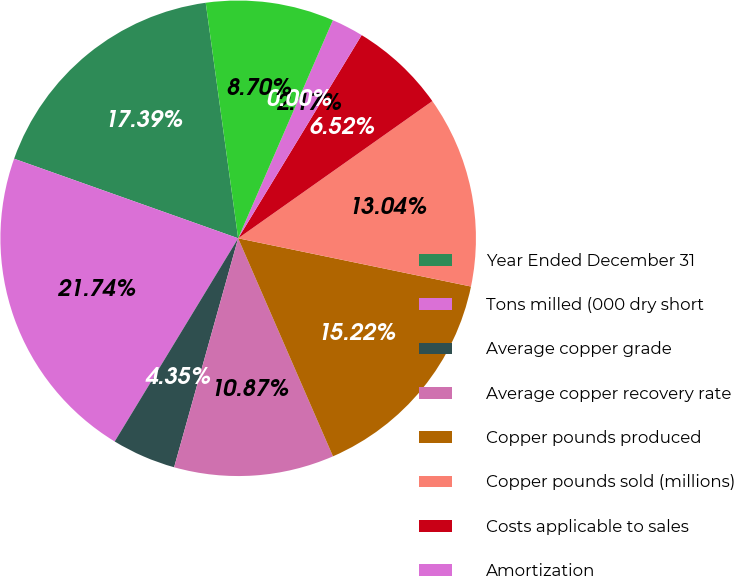<chart> <loc_0><loc_0><loc_500><loc_500><pie_chart><fcel>Year Ended December 31<fcel>Tons milled (000 dry short<fcel>Average copper grade<fcel>Average copper recovery rate<fcel>Copper pounds produced<fcel>Copper pounds sold (millions)<fcel>Costs applicable to sales<fcel>Amortization<fcel>Reclamation/accretion expense<fcel>Total production costs<nl><fcel>17.39%<fcel>21.74%<fcel>4.35%<fcel>10.87%<fcel>15.22%<fcel>13.04%<fcel>6.52%<fcel>2.17%<fcel>0.0%<fcel>8.7%<nl></chart> 